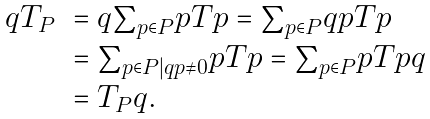<formula> <loc_0><loc_0><loc_500><loc_500>\begin{array} { r l } q T _ { P } & = q { \sum } _ { p \in P } p T p = { \sum } _ { p \in P } q p T p \\ & = { \sum } _ { p \in P | q p \neq { 0 } } p T p = { \sum } _ { p \in P } p T p q \\ & = T _ { P } q . \end{array}</formula> 